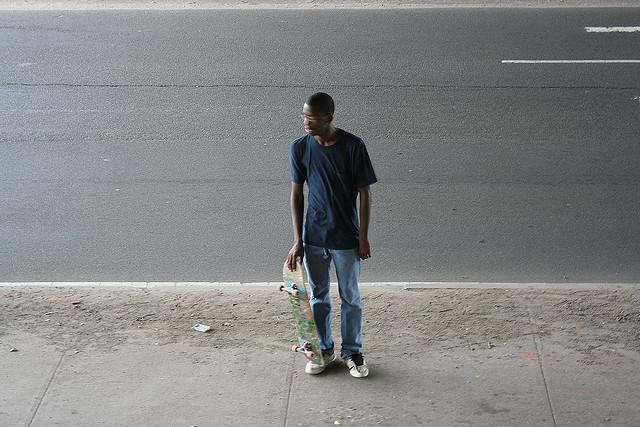Is the guy tall?
Keep it brief. Yes. Is the guy at a skate park?
Answer briefly. No. Is the boy skating?
Answer briefly. No. 